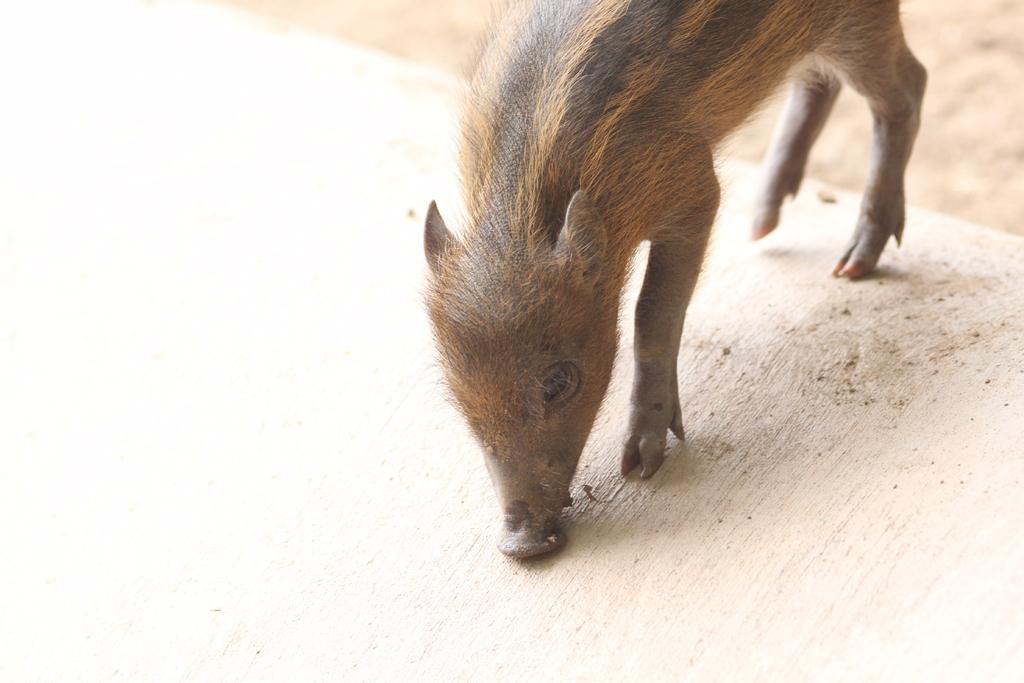What animal is present in the image? There is a pig in the image. Where is the pig located in the image? The pig is on the ground. What type of afterthought can be seen in the image? There is no afterthought present in the image; it features a pig on the ground. How many chickens are visible in the image? There are no chickens present in the image. 